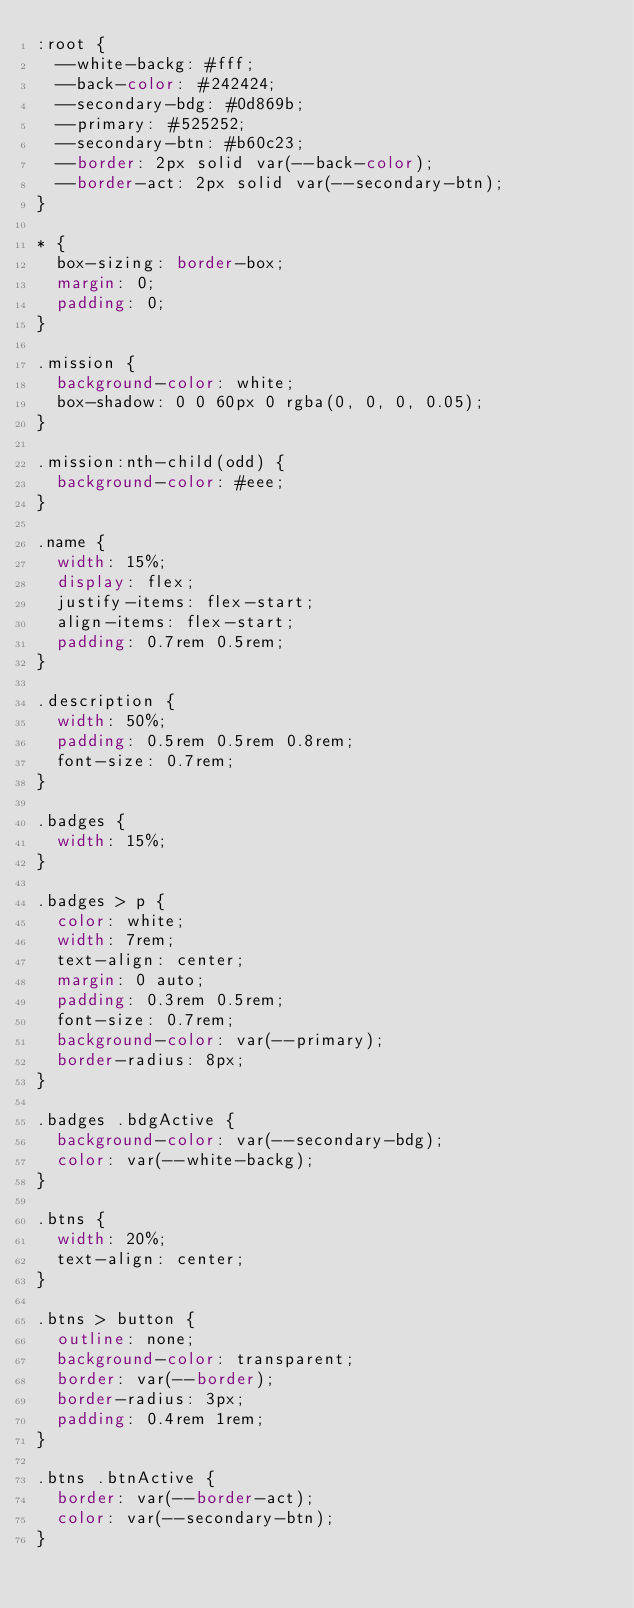<code> <loc_0><loc_0><loc_500><loc_500><_CSS_>:root {
  --white-backg: #fff;
  --back-color: #242424;
  --secondary-bdg: #0d869b;
  --primary: #525252;
  --secondary-btn: #b60c23;
  --border: 2px solid var(--back-color);
  --border-act: 2px solid var(--secondary-btn);
}

* {
  box-sizing: border-box;
  margin: 0;
  padding: 0;
}

.mission {
  background-color: white;
  box-shadow: 0 0 60px 0 rgba(0, 0, 0, 0.05);
}

.mission:nth-child(odd) {
  background-color: #eee;
}

.name {
  width: 15%;
  display: flex;
  justify-items: flex-start;
  align-items: flex-start;
  padding: 0.7rem 0.5rem;
}

.description {
  width: 50%;
  padding: 0.5rem 0.5rem 0.8rem;
  font-size: 0.7rem;
}

.badges {
  width: 15%;
}

.badges > p {
  color: white;
  width: 7rem;
  text-align: center;
  margin: 0 auto;
  padding: 0.3rem 0.5rem;
  font-size: 0.7rem;
  background-color: var(--primary);
  border-radius: 8px;
}

.badges .bdgActive {
  background-color: var(--secondary-bdg);
  color: var(--white-backg);
}

.btns {
  width: 20%;
  text-align: center;
}

.btns > button {
  outline: none;
  background-color: transparent;
  border: var(--border);
  border-radius: 3px;
  padding: 0.4rem 1rem;
}

.btns .btnActive {
  border: var(--border-act);
  color: var(--secondary-btn);
}
</code> 